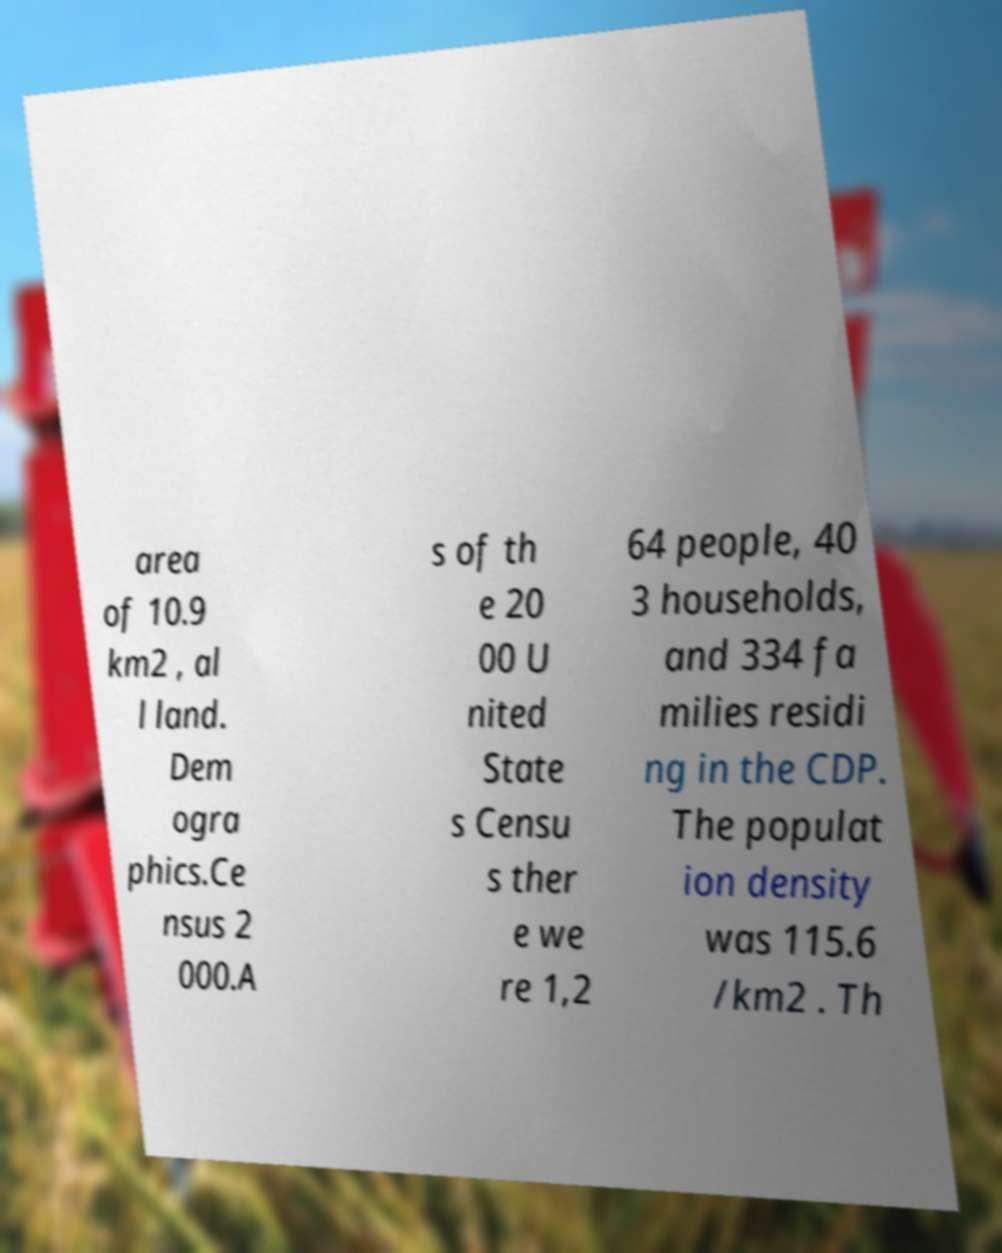For documentation purposes, I need the text within this image transcribed. Could you provide that? area of 10.9 km2 , al l land. Dem ogra phics.Ce nsus 2 000.A s of th e 20 00 U nited State s Censu s ther e we re 1,2 64 people, 40 3 households, and 334 fa milies residi ng in the CDP. The populat ion density was 115.6 /km2 . Th 